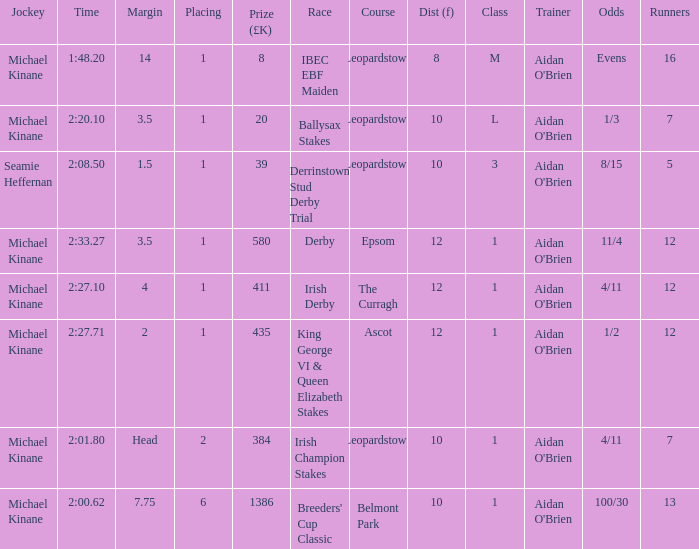Which Dist (f) has a Race of irish derby? 12.0. 